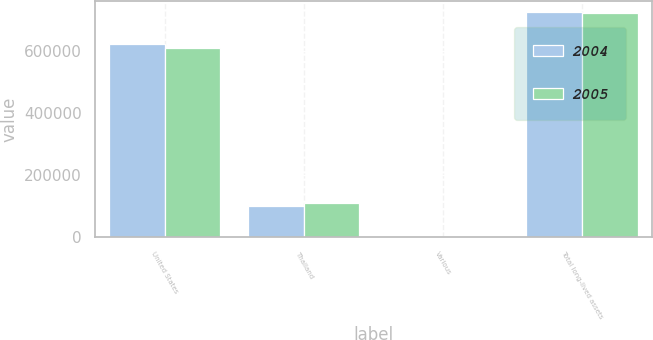Convert chart. <chart><loc_0><loc_0><loc_500><loc_500><stacked_bar_chart><ecel><fcel>United States<fcel>Thailand<fcel>Various<fcel>Total long-lived assets<nl><fcel>2004<fcel>622287<fcel>100622<fcel>2279<fcel>725188<nl><fcel>2005<fcel>608343<fcel>111730<fcel>1479<fcel>721552<nl></chart> 